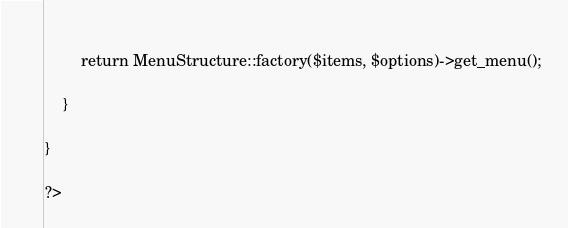<code> <loc_0><loc_0><loc_500><loc_500><_PHP_>	
        return MenuStructure::factory($items, $options)->get_menu();

    }
    
}

?>
</code> 